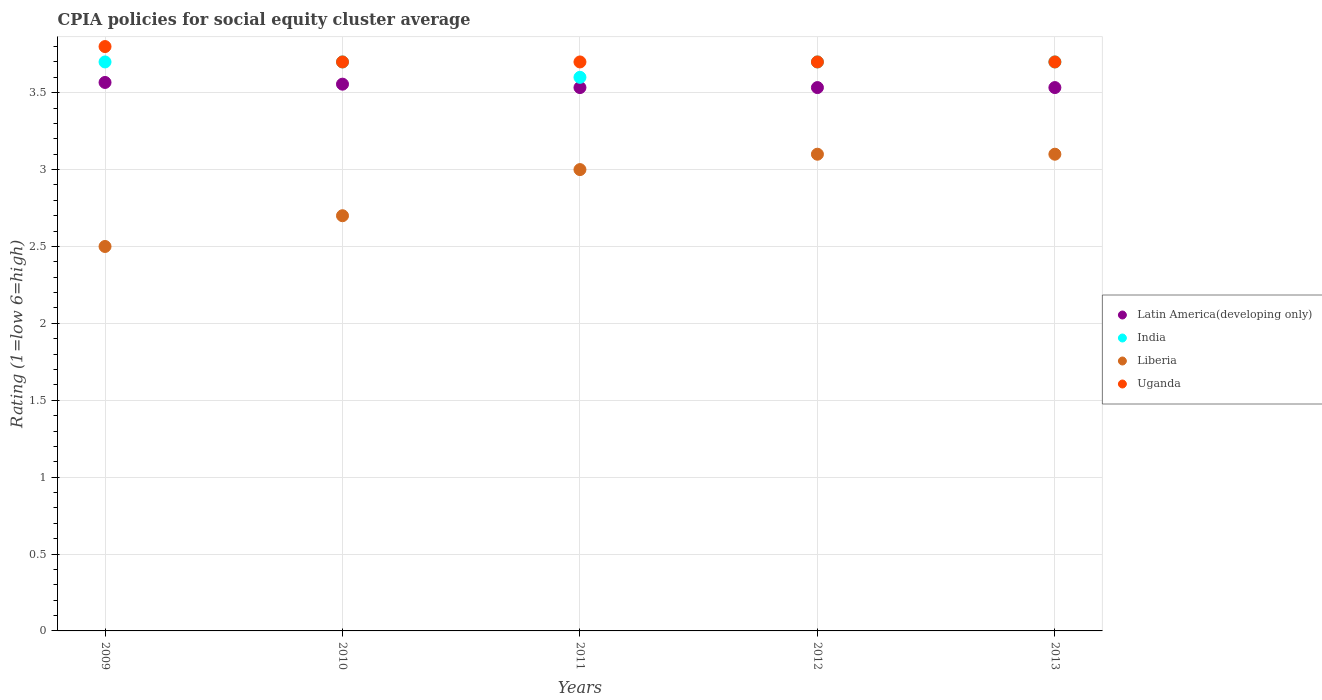Is the number of dotlines equal to the number of legend labels?
Your answer should be very brief. Yes. What is the CPIA rating in Uganda in 2011?
Provide a short and direct response. 3.7. Across all years, what is the maximum CPIA rating in Liberia?
Offer a very short reply. 3.1. In which year was the CPIA rating in Uganda minimum?
Your response must be concise. 2010. What is the total CPIA rating in Latin America(developing only) in the graph?
Provide a short and direct response. 17.72. What is the difference between the CPIA rating in India in 2009 and that in 2011?
Keep it short and to the point. 0.1. What is the difference between the CPIA rating in Uganda in 2009 and the CPIA rating in India in 2010?
Your answer should be compact. 0.1. What is the average CPIA rating in Liberia per year?
Keep it short and to the point. 2.88. In the year 2011, what is the difference between the CPIA rating in Liberia and CPIA rating in India?
Make the answer very short. -0.6. In how many years, is the CPIA rating in Uganda greater than 2.1?
Offer a very short reply. 5. What is the ratio of the CPIA rating in Uganda in 2009 to that in 2011?
Your answer should be compact. 1.03. Is the difference between the CPIA rating in Liberia in 2009 and 2012 greater than the difference between the CPIA rating in India in 2009 and 2012?
Your answer should be very brief. No. What is the difference between the highest and the second highest CPIA rating in Uganda?
Ensure brevity in your answer.  0.1. What is the difference between the highest and the lowest CPIA rating in Latin America(developing only)?
Provide a succinct answer. 0.03. In how many years, is the CPIA rating in Liberia greater than the average CPIA rating in Liberia taken over all years?
Offer a very short reply. 3. Is it the case that in every year, the sum of the CPIA rating in India and CPIA rating in Uganda  is greater than the sum of CPIA rating in Latin America(developing only) and CPIA rating in Liberia?
Your response must be concise. No. Is the CPIA rating in Liberia strictly greater than the CPIA rating in India over the years?
Provide a short and direct response. No. Is the CPIA rating in Uganda strictly less than the CPIA rating in Liberia over the years?
Keep it short and to the point. No. How many dotlines are there?
Provide a succinct answer. 4. Does the graph contain any zero values?
Your answer should be very brief. No. Where does the legend appear in the graph?
Offer a very short reply. Center right. How many legend labels are there?
Provide a succinct answer. 4. What is the title of the graph?
Your response must be concise. CPIA policies for social equity cluster average. Does "Guinea" appear as one of the legend labels in the graph?
Provide a short and direct response. No. What is the label or title of the X-axis?
Offer a very short reply. Years. What is the label or title of the Y-axis?
Your answer should be very brief. Rating (1=low 6=high). What is the Rating (1=low 6=high) in Latin America(developing only) in 2009?
Keep it short and to the point. 3.57. What is the Rating (1=low 6=high) in Uganda in 2009?
Ensure brevity in your answer.  3.8. What is the Rating (1=low 6=high) of Latin America(developing only) in 2010?
Ensure brevity in your answer.  3.56. What is the Rating (1=low 6=high) of India in 2010?
Provide a short and direct response. 3.7. What is the Rating (1=low 6=high) in Uganda in 2010?
Offer a terse response. 3.7. What is the Rating (1=low 6=high) in Latin America(developing only) in 2011?
Keep it short and to the point. 3.53. What is the Rating (1=low 6=high) in Liberia in 2011?
Ensure brevity in your answer.  3. What is the Rating (1=low 6=high) in Uganda in 2011?
Give a very brief answer. 3.7. What is the Rating (1=low 6=high) of Latin America(developing only) in 2012?
Give a very brief answer. 3.53. What is the Rating (1=low 6=high) of Latin America(developing only) in 2013?
Your answer should be very brief. 3.53. What is the Rating (1=low 6=high) in India in 2013?
Make the answer very short. 3.7. What is the Rating (1=low 6=high) of Liberia in 2013?
Provide a short and direct response. 3.1. Across all years, what is the maximum Rating (1=low 6=high) of Latin America(developing only)?
Provide a short and direct response. 3.57. Across all years, what is the maximum Rating (1=low 6=high) in Liberia?
Offer a very short reply. 3.1. Across all years, what is the minimum Rating (1=low 6=high) in Latin America(developing only)?
Offer a terse response. 3.53. Across all years, what is the minimum Rating (1=low 6=high) in India?
Keep it short and to the point. 3.6. Across all years, what is the minimum Rating (1=low 6=high) in Uganda?
Ensure brevity in your answer.  3.7. What is the total Rating (1=low 6=high) in Latin America(developing only) in the graph?
Your answer should be compact. 17.72. What is the total Rating (1=low 6=high) of Uganda in the graph?
Ensure brevity in your answer.  18.6. What is the difference between the Rating (1=low 6=high) of Latin America(developing only) in 2009 and that in 2010?
Keep it short and to the point. 0.01. What is the difference between the Rating (1=low 6=high) in Uganda in 2009 and that in 2010?
Your response must be concise. 0.1. What is the difference between the Rating (1=low 6=high) in Latin America(developing only) in 2009 and that in 2011?
Your response must be concise. 0.03. What is the difference between the Rating (1=low 6=high) in India in 2009 and that in 2011?
Provide a succinct answer. 0.1. What is the difference between the Rating (1=low 6=high) of Liberia in 2009 and that in 2011?
Your answer should be very brief. -0.5. What is the difference between the Rating (1=low 6=high) of Uganda in 2009 and that in 2011?
Keep it short and to the point. 0.1. What is the difference between the Rating (1=low 6=high) in India in 2009 and that in 2012?
Keep it short and to the point. 0. What is the difference between the Rating (1=low 6=high) of Liberia in 2009 and that in 2012?
Make the answer very short. -0.6. What is the difference between the Rating (1=low 6=high) in Uganda in 2009 and that in 2012?
Offer a very short reply. 0.1. What is the difference between the Rating (1=low 6=high) in Latin America(developing only) in 2009 and that in 2013?
Keep it short and to the point. 0.03. What is the difference between the Rating (1=low 6=high) in Liberia in 2009 and that in 2013?
Provide a short and direct response. -0.6. What is the difference between the Rating (1=low 6=high) of Latin America(developing only) in 2010 and that in 2011?
Give a very brief answer. 0.02. What is the difference between the Rating (1=low 6=high) of Latin America(developing only) in 2010 and that in 2012?
Give a very brief answer. 0.02. What is the difference between the Rating (1=low 6=high) of Liberia in 2010 and that in 2012?
Give a very brief answer. -0.4. What is the difference between the Rating (1=low 6=high) of Uganda in 2010 and that in 2012?
Your answer should be very brief. 0. What is the difference between the Rating (1=low 6=high) of Latin America(developing only) in 2010 and that in 2013?
Your response must be concise. 0.02. What is the difference between the Rating (1=low 6=high) in Liberia in 2010 and that in 2013?
Give a very brief answer. -0.4. What is the difference between the Rating (1=low 6=high) in Uganda in 2010 and that in 2013?
Offer a very short reply. 0. What is the difference between the Rating (1=low 6=high) of Liberia in 2011 and that in 2012?
Your response must be concise. -0.1. What is the difference between the Rating (1=low 6=high) of Uganda in 2011 and that in 2012?
Give a very brief answer. 0. What is the difference between the Rating (1=low 6=high) of Latin America(developing only) in 2011 and that in 2013?
Ensure brevity in your answer.  0. What is the difference between the Rating (1=low 6=high) of Uganda in 2011 and that in 2013?
Your answer should be compact. 0. What is the difference between the Rating (1=low 6=high) of Latin America(developing only) in 2012 and that in 2013?
Your answer should be very brief. 0. What is the difference between the Rating (1=low 6=high) of India in 2012 and that in 2013?
Give a very brief answer. 0. What is the difference between the Rating (1=low 6=high) of Uganda in 2012 and that in 2013?
Your answer should be compact. 0. What is the difference between the Rating (1=low 6=high) of Latin America(developing only) in 2009 and the Rating (1=low 6=high) of India in 2010?
Offer a terse response. -0.13. What is the difference between the Rating (1=low 6=high) in Latin America(developing only) in 2009 and the Rating (1=low 6=high) in Liberia in 2010?
Your answer should be compact. 0.87. What is the difference between the Rating (1=low 6=high) of Latin America(developing only) in 2009 and the Rating (1=low 6=high) of Uganda in 2010?
Your answer should be compact. -0.13. What is the difference between the Rating (1=low 6=high) of India in 2009 and the Rating (1=low 6=high) of Liberia in 2010?
Offer a very short reply. 1. What is the difference between the Rating (1=low 6=high) of India in 2009 and the Rating (1=low 6=high) of Uganda in 2010?
Offer a very short reply. 0. What is the difference between the Rating (1=low 6=high) in Latin America(developing only) in 2009 and the Rating (1=low 6=high) in India in 2011?
Offer a terse response. -0.03. What is the difference between the Rating (1=low 6=high) in Latin America(developing only) in 2009 and the Rating (1=low 6=high) in Liberia in 2011?
Give a very brief answer. 0.57. What is the difference between the Rating (1=low 6=high) in Latin America(developing only) in 2009 and the Rating (1=low 6=high) in Uganda in 2011?
Offer a very short reply. -0.13. What is the difference between the Rating (1=low 6=high) in India in 2009 and the Rating (1=low 6=high) in Liberia in 2011?
Give a very brief answer. 0.7. What is the difference between the Rating (1=low 6=high) in India in 2009 and the Rating (1=low 6=high) in Uganda in 2011?
Provide a short and direct response. 0. What is the difference between the Rating (1=low 6=high) in Latin America(developing only) in 2009 and the Rating (1=low 6=high) in India in 2012?
Your answer should be compact. -0.13. What is the difference between the Rating (1=low 6=high) in Latin America(developing only) in 2009 and the Rating (1=low 6=high) in Liberia in 2012?
Provide a short and direct response. 0.47. What is the difference between the Rating (1=low 6=high) of Latin America(developing only) in 2009 and the Rating (1=low 6=high) of Uganda in 2012?
Offer a terse response. -0.13. What is the difference between the Rating (1=low 6=high) of India in 2009 and the Rating (1=low 6=high) of Liberia in 2012?
Offer a very short reply. 0.6. What is the difference between the Rating (1=low 6=high) of India in 2009 and the Rating (1=low 6=high) of Uganda in 2012?
Make the answer very short. 0. What is the difference between the Rating (1=low 6=high) in Latin America(developing only) in 2009 and the Rating (1=low 6=high) in India in 2013?
Provide a short and direct response. -0.13. What is the difference between the Rating (1=low 6=high) in Latin America(developing only) in 2009 and the Rating (1=low 6=high) in Liberia in 2013?
Give a very brief answer. 0.47. What is the difference between the Rating (1=low 6=high) in Latin America(developing only) in 2009 and the Rating (1=low 6=high) in Uganda in 2013?
Give a very brief answer. -0.13. What is the difference between the Rating (1=low 6=high) in India in 2009 and the Rating (1=low 6=high) in Liberia in 2013?
Provide a short and direct response. 0.6. What is the difference between the Rating (1=low 6=high) in India in 2009 and the Rating (1=low 6=high) in Uganda in 2013?
Make the answer very short. 0. What is the difference between the Rating (1=low 6=high) in Latin America(developing only) in 2010 and the Rating (1=low 6=high) in India in 2011?
Make the answer very short. -0.04. What is the difference between the Rating (1=low 6=high) in Latin America(developing only) in 2010 and the Rating (1=low 6=high) in Liberia in 2011?
Give a very brief answer. 0.56. What is the difference between the Rating (1=low 6=high) in Latin America(developing only) in 2010 and the Rating (1=low 6=high) in Uganda in 2011?
Offer a very short reply. -0.14. What is the difference between the Rating (1=low 6=high) in Liberia in 2010 and the Rating (1=low 6=high) in Uganda in 2011?
Give a very brief answer. -1. What is the difference between the Rating (1=low 6=high) of Latin America(developing only) in 2010 and the Rating (1=low 6=high) of India in 2012?
Your answer should be very brief. -0.14. What is the difference between the Rating (1=low 6=high) in Latin America(developing only) in 2010 and the Rating (1=low 6=high) in Liberia in 2012?
Offer a very short reply. 0.46. What is the difference between the Rating (1=low 6=high) in Latin America(developing only) in 2010 and the Rating (1=low 6=high) in Uganda in 2012?
Ensure brevity in your answer.  -0.14. What is the difference between the Rating (1=low 6=high) of Liberia in 2010 and the Rating (1=low 6=high) of Uganda in 2012?
Keep it short and to the point. -1. What is the difference between the Rating (1=low 6=high) in Latin America(developing only) in 2010 and the Rating (1=low 6=high) in India in 2013?
Keep it short and to the point. -0.14. What is the difference between the Rating (1=low 6=high) of Latin America(developing only) in 2010 and the Rating (1=low 6=high) of Liberia in 2013?
Give a very brief answer. 0.46. What is the difference between the Rating (1=low 6=high) in Latin America(developing only) in 2010 and the Rating (1=low 6=high) in Uganda in 2013?
Make the answer very short. -0.14. What is the difference between the Rating (1=low 6=high) of India in 2010 and the Rating (1=low 6=high) of Uganda in 2013?
Keep it short and to the point. 0. What is the difference between the Rating (1=low 6=high) of Latin America(developing only) in 2011 and the Rating (1=low 6=high) of India in 2012?
Your response must be concise. -0.17. What is the difference between the Rating (1=low 6=high) in Latin America(developing only) in 2011 and the Rating (1=low 6=high) in Liberia in 2012?
Offer a terse response. 0.43. What is the difference between the Rating (1=low 6=high) of Latin America(developing only) in 2011 and the Rating (1=low 6=high) of Uganda in 2012?
Ensure brevity in your answer.  -0.17. What is the difference between the Rating (1=low 6=high) of India in 2011 and the Rating (1=low 6=high) of Uganda in 2012?
Offer a very short reply. -0.1. What is the difference between the Rating (1=low 6=high) in Latin America(developing only) in 2011 and the Rating (1=low 6=high) in Liberia in 2013?
Provide a short and direct response. 0.43. What is the difference between the Rating (1=low 6=high) of Latin America(developing only) in 2011 and the Rating (1=low 6=high) of Uganda in 2013?
Offer a terse response. -0.17. What is the difference between the Rating (1=low 6=high) of India in 2011 and the Rating (1=low 6=high) of Liberia in 2013?
Offer a very short reply. 0.5. What is the difference between the Rating (1=low 6=high) in India in 2011 and the Rating (1=low 6=high) in Uganda in 2013?
Offer a terse response. -0.1. What is the difference between the Rating (1=low 6=high) in Latin America(developing only) in 2012 and the Rating (1=low 6=high) in India in 2013?
Your response must be concise. -0.17. What is the difference between the Rating (1=low 6=high) of Latin America(developing only) in 2012 and the Rating (1=low 6=high) of Liberia in 2013?
Keep it short and to the point. 0.43. What is the difference between the Rating (1=low 6=high) in Latin America(developing only) in 2012 and the Rating (1=low 6=high) in Uganda in 2013?
Give a very brief answer. -0.17. What is the difference between the Rating (1=low 6=high) in India in 2012 and the Rating (1=low 6=high) in Liberia in 2013?
Offer a terse response. 0.6. What is the difference between the Rating (1=low 6=high) in India in 2012 and the Rating (1=low 6=high) in Uganda in 2013?
Make the answer very short. 0. What is the average Rating (1=low 6=high) in Latin America(developing only) per year?
Make the answer very short. 3.54. What is the average Rating (1=low 6=high) in India per year?
Your answer should be very brief. 3.68. What is the average Rating (1=low 6=high) in Liberia per year?
Ensure brevity in your answer.  2.88. What is the average Rating (1=low 6=high) of Uganda per year?
Offer a very short reply. 3.72. In the year 2009, what is the difference between the Rating (1=low 6=high) in Latin America(developing only) and Rating (1=low 6=high) in India?
Provide a short and direct response. -0.13. In the year 2009, what is the difference between the Rating (1=low 6=high) of Latin America(developing only) and Rating (1=low 6=high) of Liberia?
Give a very brief answer. 1.07. In the year 2009, what is the difference between the Rating (1=low 6=high) in Latin America(developing only) and Rating (1=low 6=high) in Uganda?
Your answer should be compact. -0.23. In the year 2010, what is the difference between the Rating (1=low 6=high) of Latin America(developing only) and Rating (1=low 6=high) of India?
Your answer should be very brief. -0.14. In the year 2010, what is the difference between the Rating (1=low 6=high) in Latin America(developing only) and Rating (1=low 6=high) in Liberia?
Ensure brevity in your answer.  0.86. In the year 2010, what is the difference between the Rating (1=low 6=high) in Latin America(developing only) and Rating (1=low 6=high) in Uganda?
Provide a short and direct response. -0.14. In the year 2010, what is the difference between the Rating (1=low 6=high) in Liberia and Rating (1=low 6=high) in Uganda?
Provide a short and direct response. -1. In the year 2011, what is the difference between the Rating (1=low 6=high) in Latin America(developing only) and Rating (1=low 6=high) in India?
Offer a very short reply. -0.07. In the year 2011, what is the difference between the Rating (1=low 6=high) of Latin America(developing only) and Rating (1=low 6=high) of Liberia?
Give a very brief answer. 0.53. In the year 2012, what is the difference between the Rating (1=low 6=high) of Latin America(developing only) and Rating (1=low 6=high) of Liberia?
Offer a very short reply. 0.43. In the year 2012, what is the difference between the Rating (1=low 6=high) in Latin America(developing only) and Rating (1=low 6=high) in Uganda?
Offer a very short reply. -0.17. In the year 2012, what is the difference between the Rating (1=low 6=high) of Liberia and Rating (1=low 6=high) of Uganda?
Ensure brevity in your answer.  -0.6. In the year 2013, what is the difference between the Rating (1=low 6=high) of Latin America(developing only) and Rating (1=low 6=high) of Liberia?
Your answer should be very brief. 0.43. In the year 2013, what is the difference between the Rating (1=low 6=high) in Liberia and Rating (1=low 6=high) in Uganda?
Give a very brief answer. -0.6. What is the ratio of the Rating (1=low 6=high) in Latin America(developing only) in 2009 to that in 2010?
Offer a very short reply. 1. What is the ratio of the Rating (1=low 6=high) in India in 2009 to that in 2010?
Give a very brief answer. 1. What is the ratio of the Rating (1=low 6=high) in Liberia in 2009 to that in 2010?
Offer a very short reply. 0.93. What is the ratio of the Rating (1=low 6=high) of Uganda in 2009 to that in 2010?
Provide a short and direct response. 1.03. What is the ratio of the Rating (1=low 6=high) of Latin America(developing only) in 2009 to that in 2011?
Your response must be concise. 1.01. What is the ratio of the Rating (1=low 6=high) of India in 2009 to that in 2011?
Give a very brief answer. 1.03. What is the ratio of the Rating (1=low 6=high) in Liberia in 2009 to that in 2011?
Ensure brevity in your answer.  0.83. What is the ratio of the Rating (1=low 6=high) of Latin America(developing only) in 2009 to that in 2012?
Offer a very short reply. 1.01. What is the ratio of the Rating (1=low 6=high) of Liberia in 2009 to that in 2012?
Offer a terse response. 0.81. What is the ratio of the Rating (1=low 6=high) in Latin America(developing only) in 2009 to that in 2013?
Your answer should be compact. 1.01. What is the ratio of the Rating (1=low 6=high) of India in 2009 to that in 2013?
Your answer should be very brief. 1. What is the ratio of the Rating (1=low 6=high) of Liberia in 2009 to that in 2013?
Offer a very short reply. 0.81. What is the ratio of the Rating (1=low 6=high) in India in 2010 to that in 2011?
Your answer should be compact. 1.03. What is the ratio of the Rating (1=low 6=high) in Liberia in 2010 to that in 2011?
Give a very brief answer. 0.9. What is the ratio of the Rating (1=low 6=high) in Uganda in 2010 to that in 2011?
Make the answer very short. 1. What is the ratio of the Rating (1=low 6=high) of Latin America(developing only) in 2010 to that in 2012?
Give a very brief answer. 1.01. What is the ratio of the Rating (1=low 6=high) in India in 2010 to that in 2012?
Your response must be concise. 1. What is the ratio of the Rating (1=low 6=high) of Liberia in 2010 to that in 2012?
Keep it short and to the point. 0.87. What is the ratio of the Rating (1=low 6=high) in Uganda in 2010 to that in 2012?
Ensure brevity in your answer.  1. What is the ratio of the Rating (1=low 6=high) of Latin America(developing only) in 2010 to that in 2013?
Offer a very short reply. 1.01. What is the ratio of the Rating (1=low 6=high) of India in 2010 to that in 2013?
Offer a terse response. 1. What is the ratio of the Rating (1=low 6=high) in Liberia in 2010 to that in 2013?
Your response must be concise. 0.87. What is the ratio of the Rating (1=low 6=high) in Uganda in 2011 to that in 2012?
Ensure brevity in your answer.  1. What is the ratio of the Rating (1=low 6=high) in Liberia in 2011 to that in 2013?
Make the answer very short. 0.97. What is the ratio of the Rating (1=low 6=high) of Uganda in 2011 to that in 2013?
Provide a succinct answer. 1. What is the ratio of the Rating (1=low 6=high) of Latin America(developing only) in 2012 to that in 2013?
Keep it short and to the point. 1. What is the ratio of the Rating (1=low 6=high) in India in 2012 to that in 2013?
Keep it short and to the point. 1. What is the ratio of the Rating (1=low 6=high) of Liberia in 2012 to that in 2013?
Keep it short and to the point. 1. What is the difference between the highest and the second highest Rating (1=low 6=high) in Latin America(developing only)?
Provide a short and direct response. 0.01. What is the difference between the highest and the second highest Rating (1=low 6=high) in Uganda?
Offer a terse response. 0.1. What is the difference between the highest and the lowest Rating (1=low 6=high) of Latin America(developing only)?
Your response must be concise. 0.03. What is the difference between the highest and the lowest Rating (1=low 6=high) of India?
Ensure brevity in your answer.  0.1. What is the difference between the highest and the lowest Rating (1=low 6=high) of Liberia?
Give a very brief answer. 0.6. 